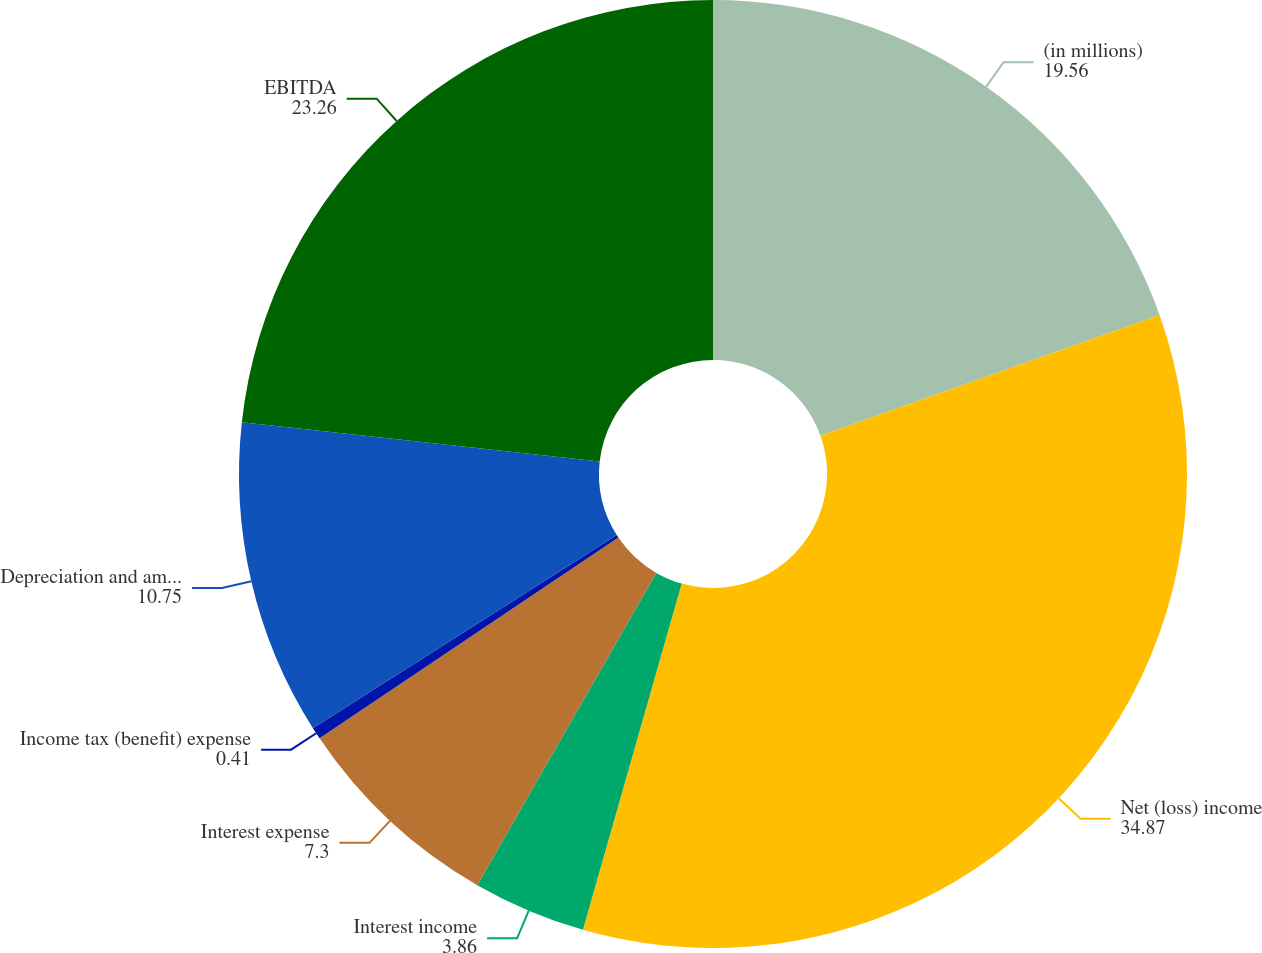<chart> <loc_0><loc_0><loc_500><loc_500><pie_chart><fcel>(in millions)<fcel>Net (loss) income<fcel>Interest income<fcel>Interest expense<fcel>Income tax (benefit) expense<fcel>Depreciation and amortization<fcel>EBITDA<nl><fcel>19.56%<fcel>34.87%<fcel>3.86%<fcel>7.3%<fcel>0.41%<fcel>10.75%<fcel>23.26%<nl></chart> 